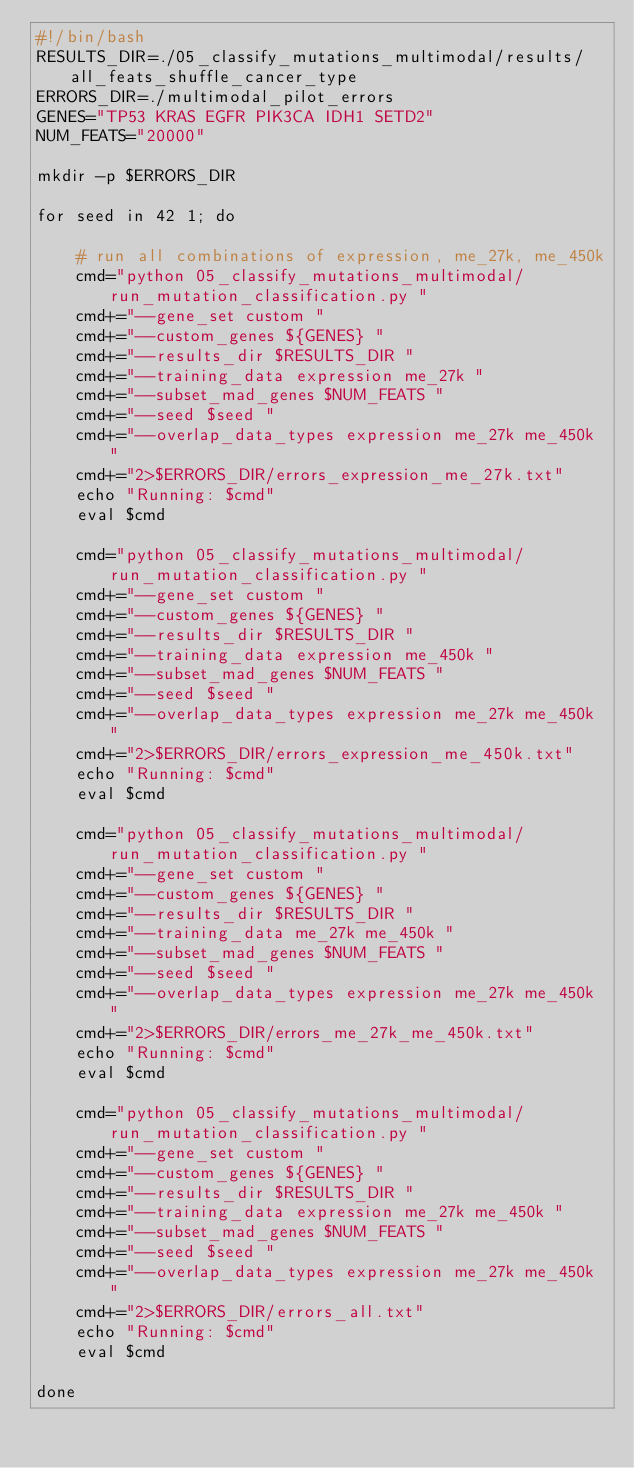<code> <loc_0><loc_0><loc_500><loc_500><_Bash_>#!/bin/bash
RESULTS_DIR=./05_classify_mutations_multimodal/results/all_feats_shuffle_cancer_type
ERRORS_DIR=./multimodal_pilot_errors
GENES="TP53 KRAS EGFR PIK3CA IDH1 SETD2"
NUM_FEATS="20000"

mkdir -p $ERRORS_DIR

for seed in 42 1; do

    # run all combinations of expression, me_27k, me_450k
    cmd="python 05_classify_mutations_multimodal/run_mutation_classification.py "
    cmd+="--gene_set custom "
    cmd+="--custom_genes ${GENES} "
    cmd+="--results_dir $RESULTS_DIR "
    cmd+="--training_data expression me_27k "
    cmd+="--subset_mad_genes $NUM_FEATS "
    cmd+="--seed $seed "
    cmd+="--overlap_data_types expression me_27k me_450k "
    cmd+="2>$ERRORS_DIR/errors_expression_me_27k.txt"
    echo "Running: $cmd"
    eval $cmd

    cmd="python 05_classify_mutations_multimodal/run_mutation_classification.py "
    cmd+="--gene_set custom "
    cmd+="--custom_genes ${GENES} "
    cmd+="--results_dir $RESULTS_DIR "
    cmd+="--training_data expression me_450k "
    cmd+="--subset_mad_genes $NUM_FEATS "
    cmd+="--seed $seed "
    cmd+="--overlap_data_types expression me_27k me_450k "
    cmd+="2>$ERRORS_DIR/errors_expression_me_450k.txt"
    echo "Running: $cmd"
    eval $cmd

    cmd="python 05_classify_mutations_multimodal/run_mutation_classification.py "
    cmd+="--gene_set custom "
    cmd+="--custom_genes ${GENES} "
    cmd+="--results_dir $RESULTS_DIR "
    cmd+="--training_data me_27k me_450k "
    cmd+="--subset_mad_genes $NUM_FEATS "
    cmd+="--seed $seed "
    cmd+="--overlap_data_types expression me_27k me_450k "
    cmd+="2>$ERRORS_DIR/errors_me_27k_me_450k.txt"
    echo "Running: $cmd"
    eval $cmd

    cmd="python 05_classify_mutations_multimodal/run_mutation_classification.py "
    cmd+="--gene_set custom "
    cmd+="--custom_genes ${GENES} "
    cmd+="--results_dir $RESULTS_DIR "
    cmd+="--training_data expression me_27k me_450k "
    cmd+="--subset_mad_genes $NUM_FEATS "
    cmd+="--seed $seed "
    cmd+="--overlap_data_types expression me_27k me_450k "
    cmd+="2>$ERRORS_DIR/errors_all.txt"
    echo "Running: $cmd"
    eval $cmd

done
</code> 